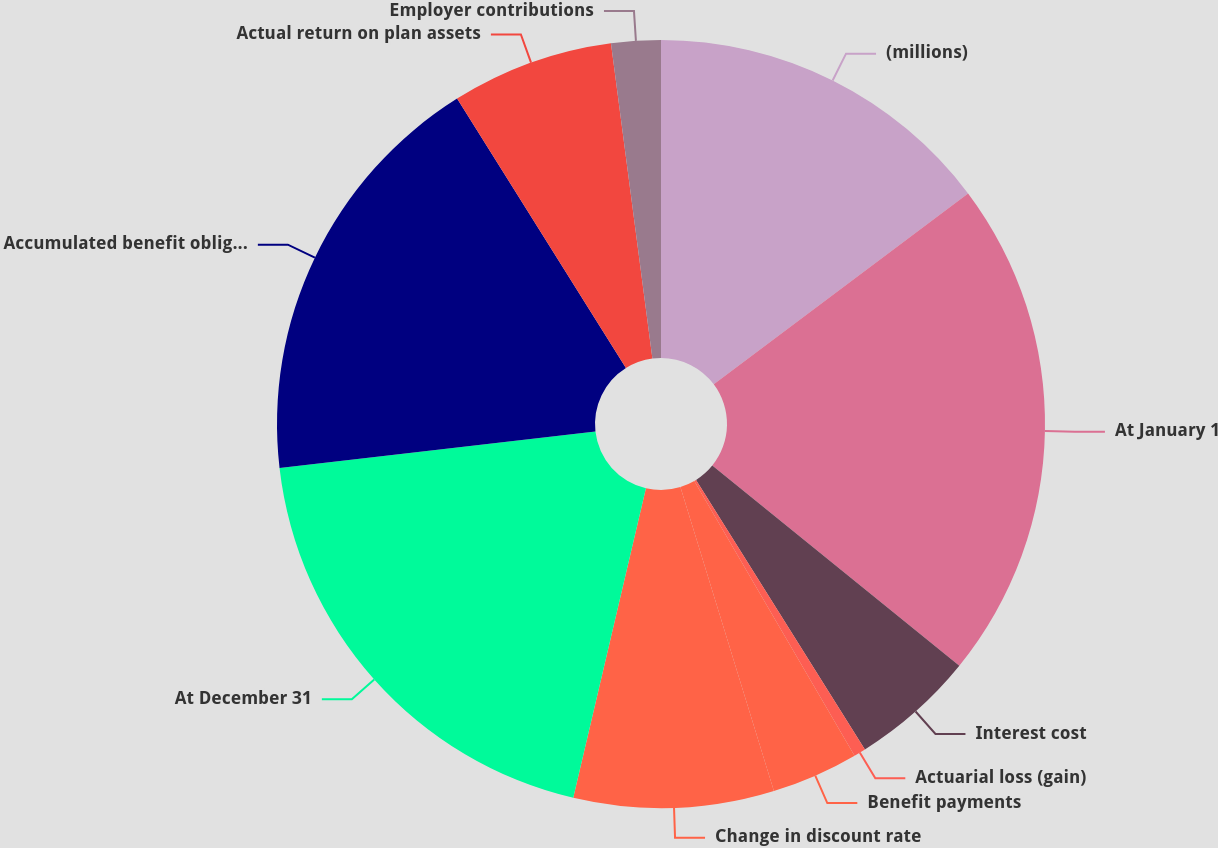Convert chart. <chart><loc_0><loc_0><loc_500><loc_500><pie_chart><fcel>(millions)<fcel>At January 1<fcel>Interest cost<fcel>Actuarial loss (gain)<fcel>Benefit payments<fcel>Change in discount rate<fcel>At December 31<fcel>Accumulated benefit obligation<fcel>Actual return on plan assets<fcel>Employer contributions<nl><fcel>14.75%<fcel>21.09%<fcel>5.25%<fcel>0.5%<fcel>3.66%<fcel>8.42%<fcel>19.5%<fcel>17.92%<fcel>6.83%<fcel>2.08%<nl></chart> 